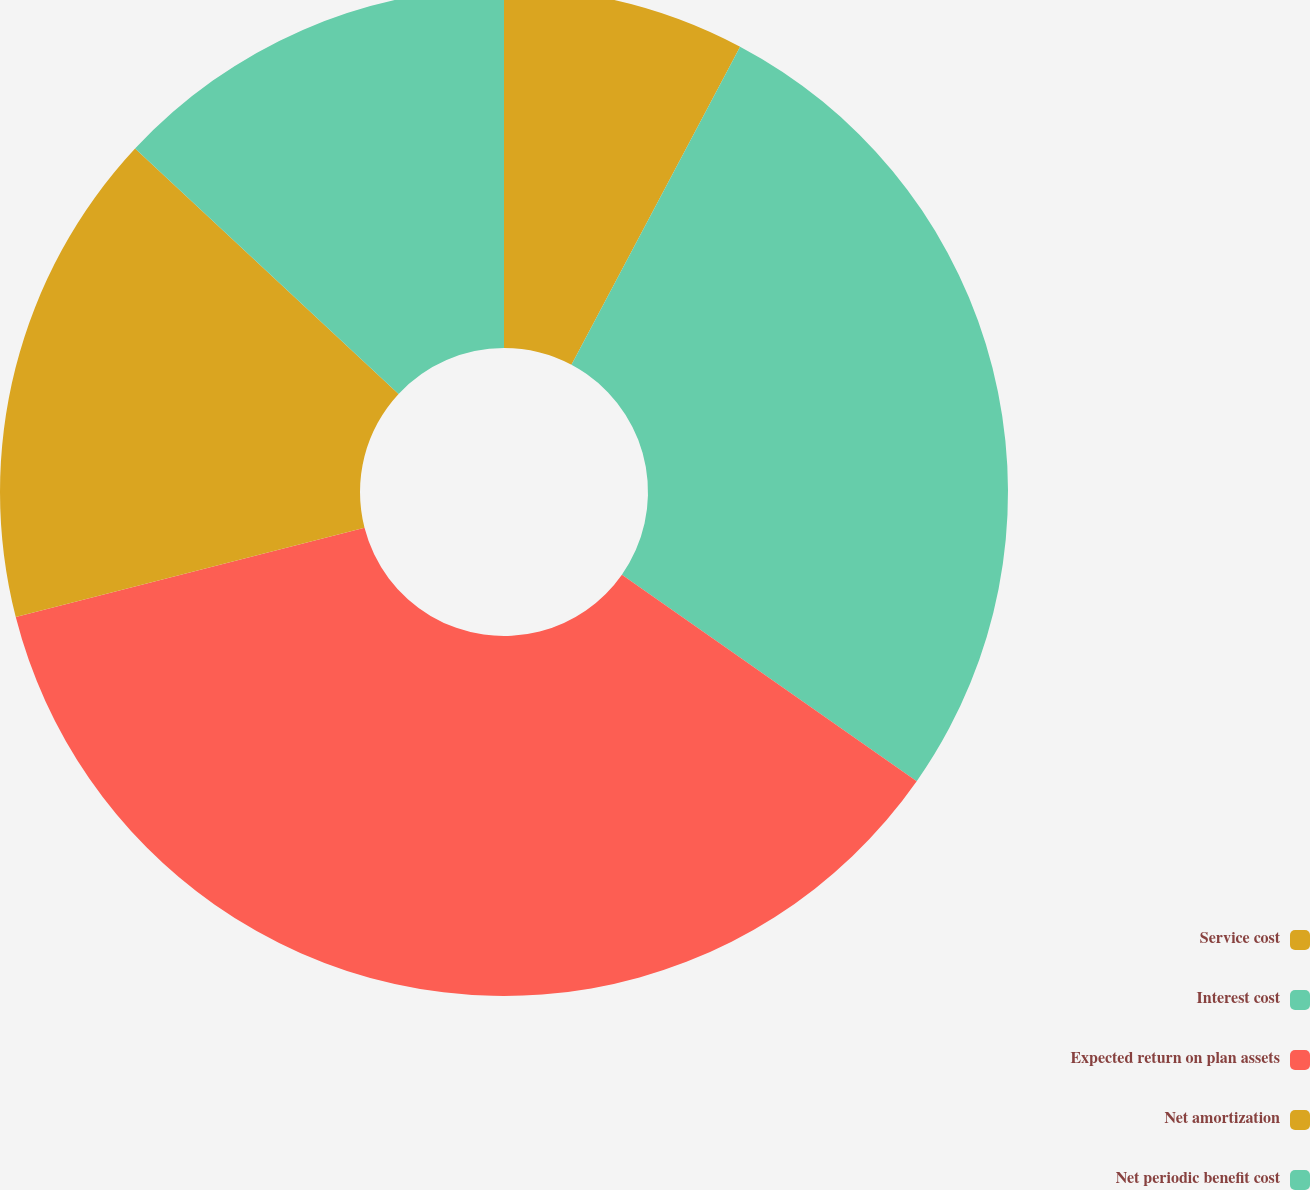<chart> <loc_0><loc_0><loc_500><loc_500><pie_chart><fcel>Service cost<fcel>Interest cost<fcel>Expected return on plan assets<fcel>Net amortization<fcel>Net periodic benefit cost<nl><fcel>7.76%<fcel>26.97%<fcel>36.28%<fcel>15.92%<fcel>13.07%<nl></chart> 